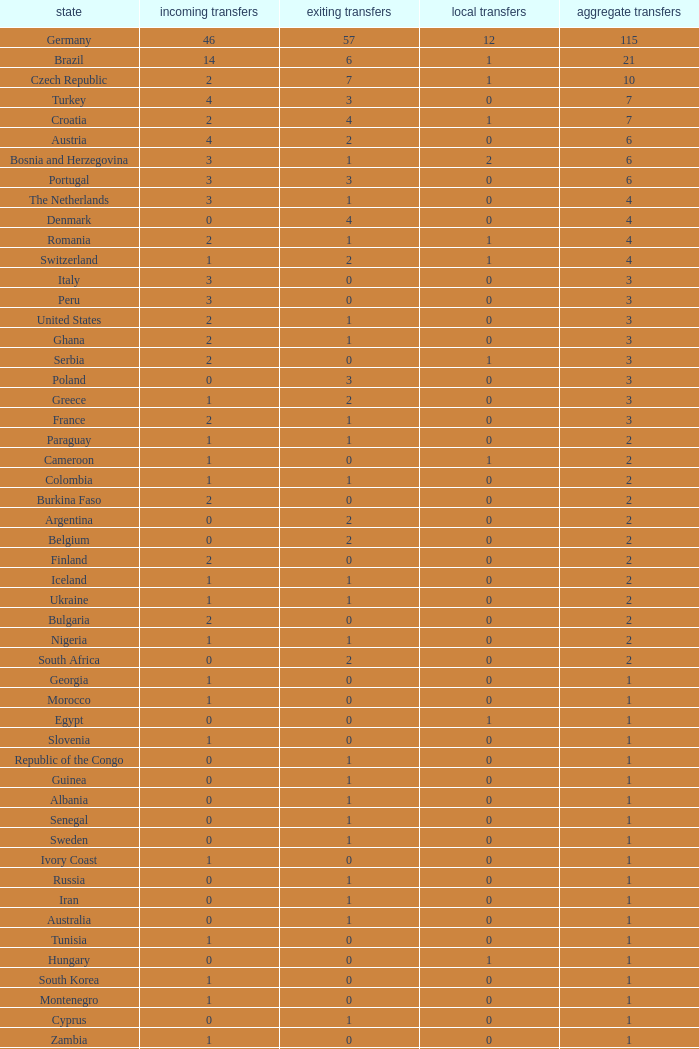What are the Transfers out for Peru? 0.0. 